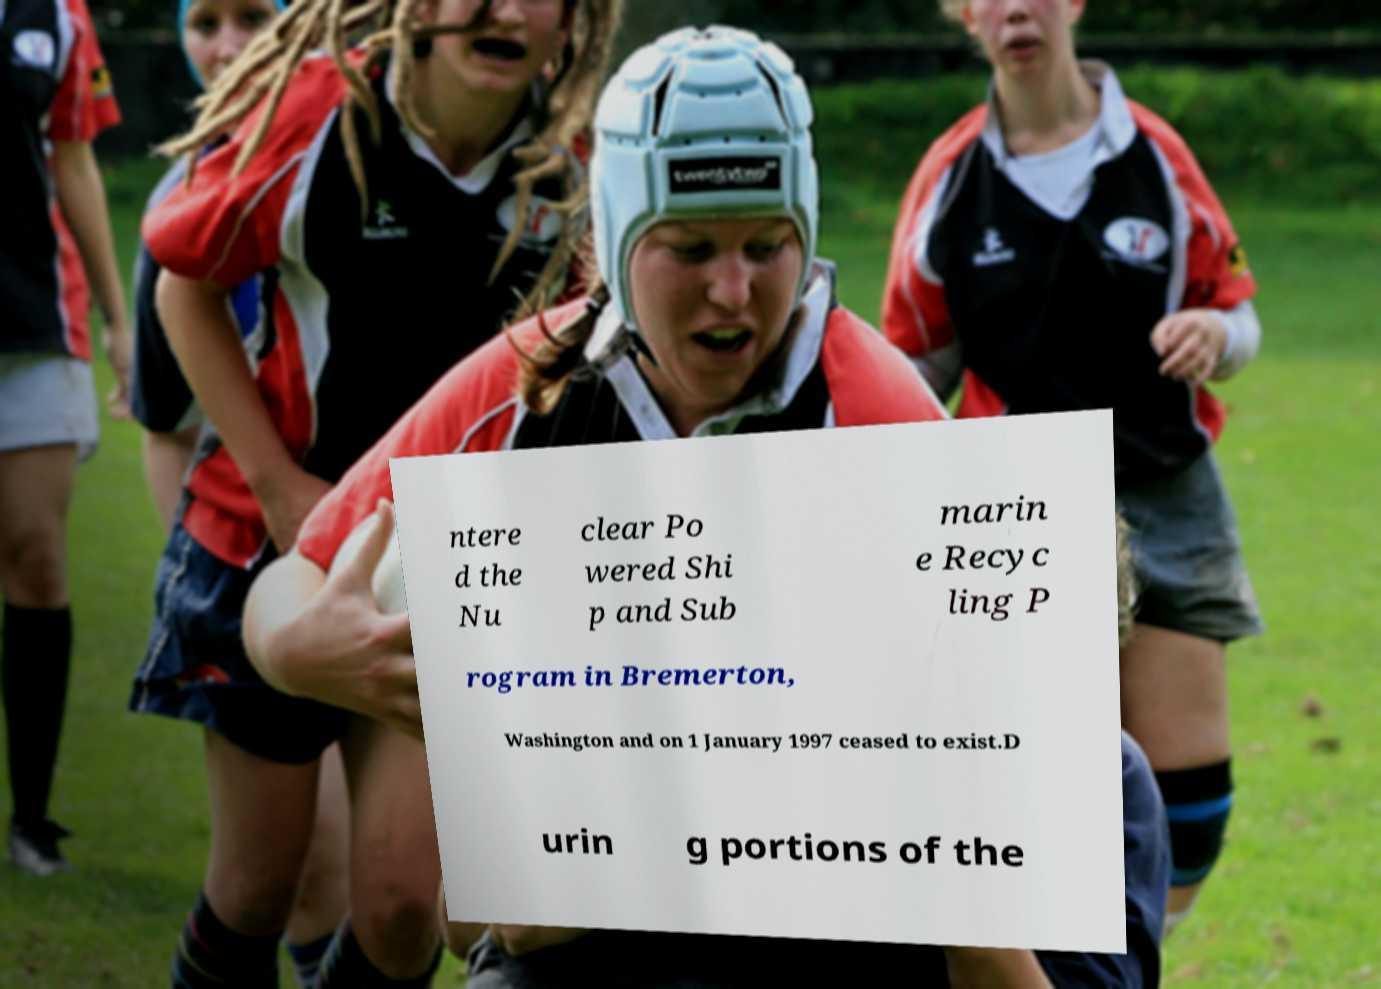Please identify and transcribe the text found in this image. ntere d the Nu clear Po wered Shi p and Sub marin e Recyc ling P rogram in Bremerton, Washington and on 1 January 1997 ceased to exist.D urin g portions of the 